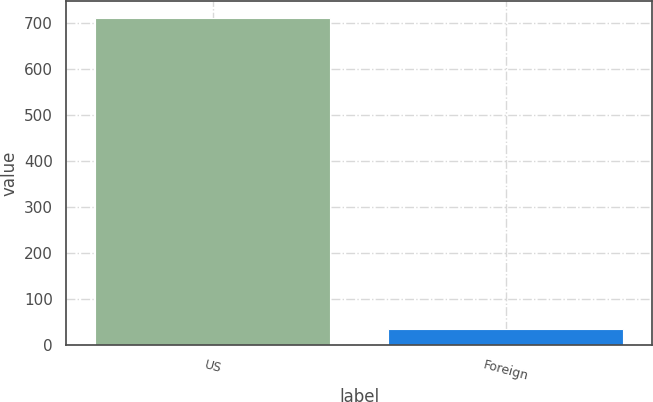Convert chart to OTSL. <chart><loc_0><loc_0><loc_500><loc_500><bar_chart><fcel>US<fcel>Foreign<nl><fcel>711.1<fcel>35.5<nl></chart> 